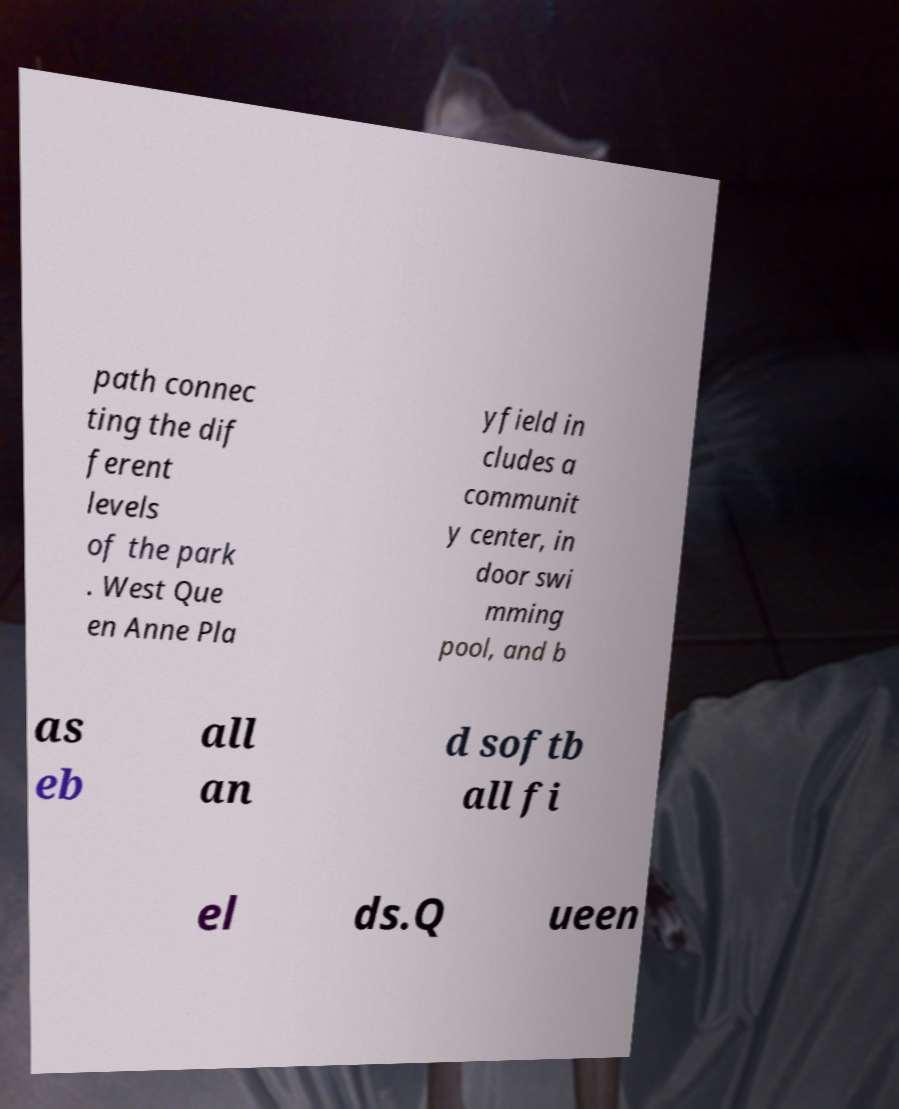Could you extract and type out the text from this image? path connec ting the dif ferent levels of the park . West Que en Anne Pla yfield in cludes a communit y center, in door swi mming pool, and b as eb all an d softb all fi el ds.Q ueen 